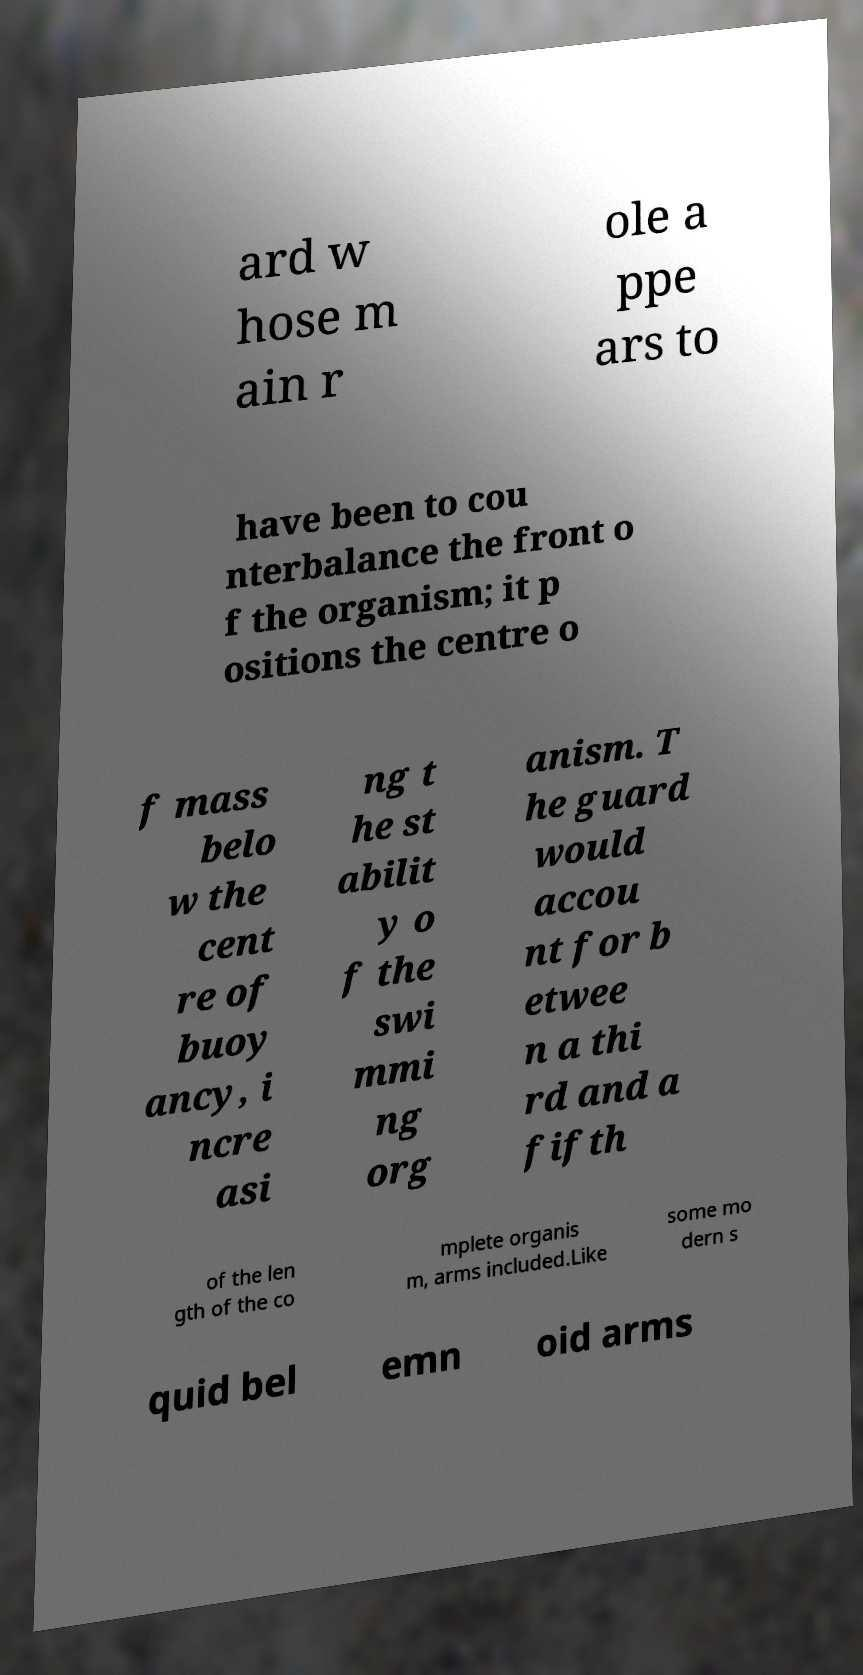There's text embedded in this image that I need extracted. Can you transcribe it verbatim? ard w hose m ain r ole a ppe ars to have been to cou nterbalance the front o f the organism; it p ositions the centre o f mass belo w the cent re of buoy ancy, i ncre asi ng t he st abilit y o f the swi mmi ng org anism. T he guard would accou nt for b etwee n a thi rd and a fifth of the len gth of the co mplete organis m, arms included.Like some mo dern s quid bel emn oid arms 